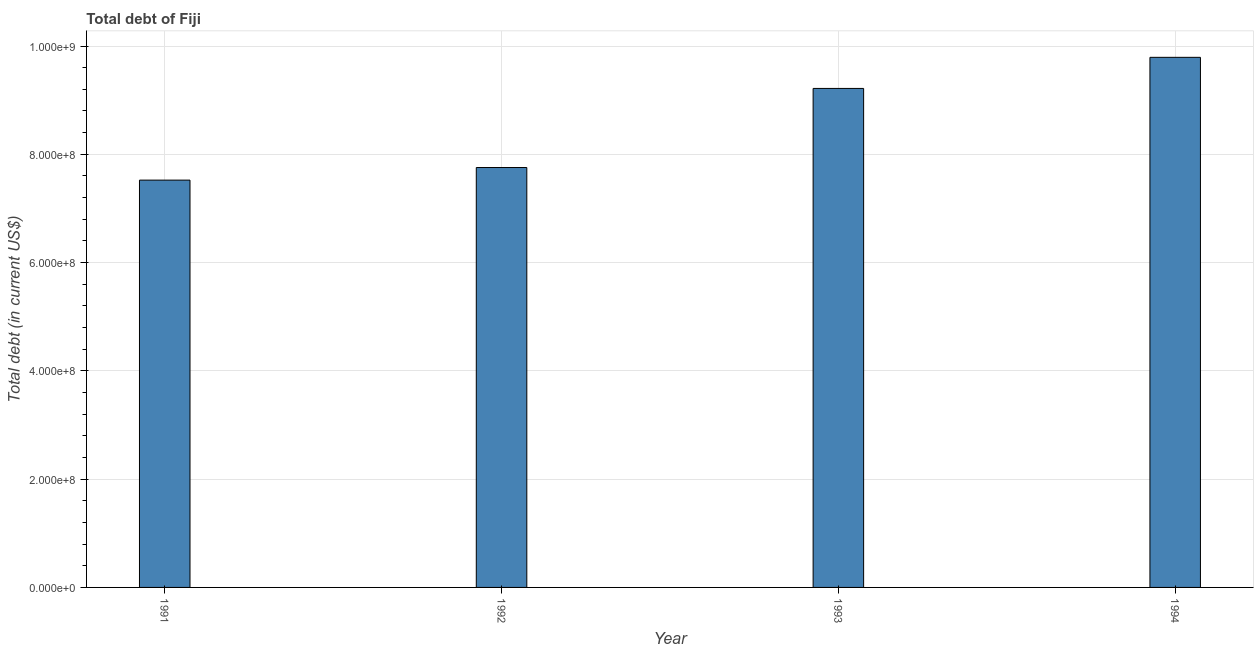Does the graph contain any zero values?
Your response must be concise. No. Does the graph contain grids?
Your answer should be very brief. Yes. What is the title of the graph?
Provide a succinct answer. Total debt of Fiji. What is the label or title of the Y-axis?
Offer a terse response. Total debt (in current US$). What is the total debt in 1991?
Make the answer very short. 7.52e+08. Across all years, what is the maximum total debt?
Make the answer very short. 9.79e+08. Across all years, what is the minimum total debt?
Ensure brevity in your answer.  7.52e+08. What is the sum of the total debt?
Your response must be concise. 3.43e+09. What is the difference between the total debt in 1991 and 1992?
Your response must be concise. -2.33e+07. What is the average total debt per year?
Provide a succinct answer. 8.57e+08. What is the median total debt?
Your answer should be compact. 8.49e+08. In how many years, is the total debt greater than 840000000 US$?
Your response must be concise. 2. What is the ratio of the total debt in 1993 to that in 1994?
Your answer should be very brief. 0.94. Is the difference between the total debt in 1992 and 1993 greater than the difference between any two years?
Offer a terse response. No. What is the difference between the highest and the second highest total debt?
Give a very brief answer. 5.74e+07. What is the difference between the highest and the lowest total debt?
Ensure brevity in your answer.  2.27e+08. In how many years, is the total debt greater than the average total debt taken over all years?
Make the answer very short. 2. How many bars are there?
Offer a terse response. 4. Are all the bars in the graph horizontal?
Your answer should be very brief. No. What is the difference between two consecutive major ticks on the Y-axis?
Give a very brief answer. 2.00e+08. What is the Total debt (in current US$) of 1991?
Your answer should be compact. 7.52e+08. What is the Total debt (in current US$) in 1992?
Your answer should be very brief. 7.76e+08. What is the Total debt (in current US$) in 1993?
Your response must be concise. 9.22e+08. What is the Total debt (in current US$) of 1994?
Your answer should be compact. 9.79e+08. What is the difference between the Total debt (in current US$) in 1991 and 1992?
Your answer should be compact. -2.33e+07. What is the difference between the Total debt (in current US$) in 1991 and 1993?
Provide a short and direct response. -1.69e+08. What is the difference between the Total debt (in current US$) in 1991 and 1994?
Provide a short and direct response. -2.27e+08. What is the difference between the Total debt (in current US$) in 1992 and 1993?
Provide a short and direct response. -1.46e+08. What is the difference between the Total debt (in current US$) in 1992 and 1994?
Offer a terse response. -2.04e+08. What is the difference between the Total debt (in current US$) in 1993 and 1994?
Offer a very short reply. -5.74e+07. What is the ratio of the Total debt (in current US$) in 1991 to that in 1993?
Your answer should be very brief. 0.82. What is the ratio of the Total debt (in current US$) in 1991 to that in 1994?
Provide a short and direct response. 0.77. What is the ratio of the Total debt (in current US$) in 1992 to that in 1993?
Your response must be concise. 0.84. What is the ratio of the Total debt (in current US$) in 1992 to that in 1994?
Ensure brevity in your answer.  0.79. What is the ratio of the Total debt (in current US$) in 1993 to that in 1994?
Give a very brief answer. 0.94. 